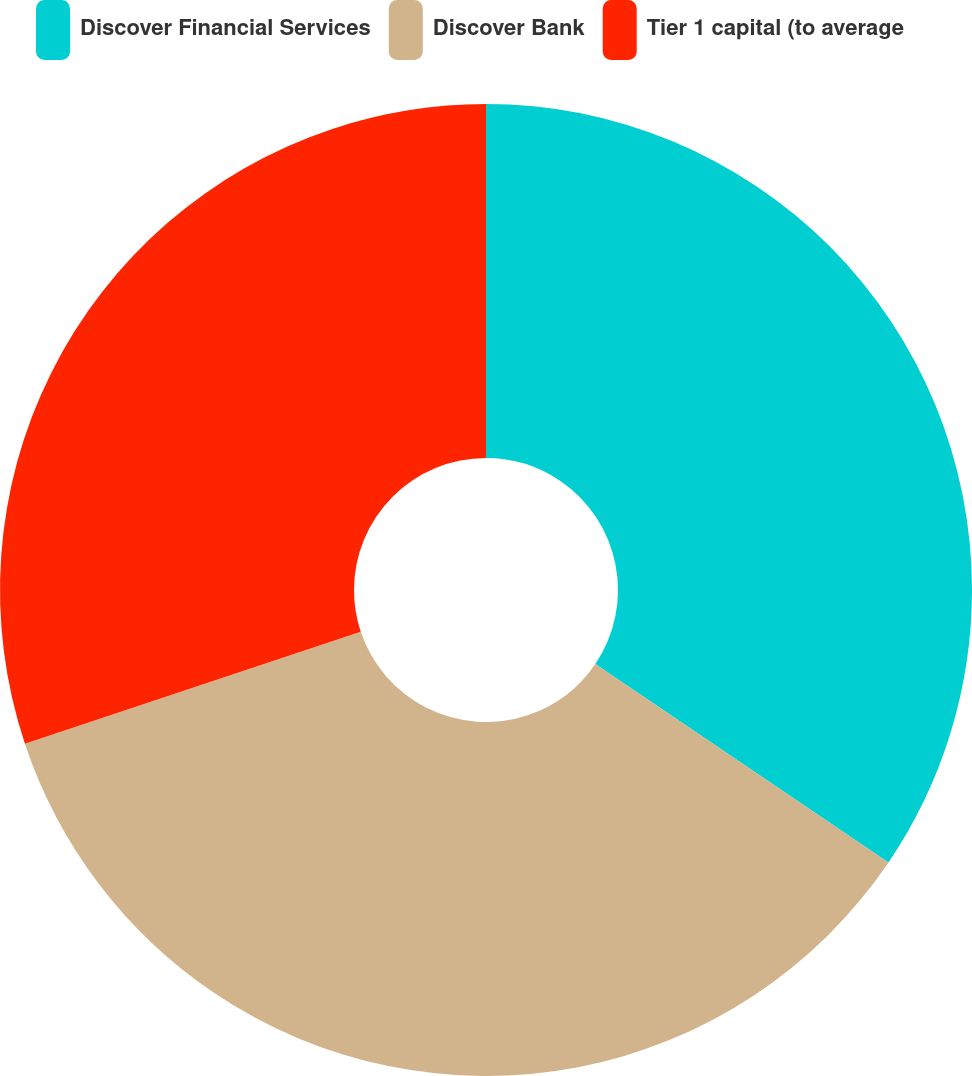Convert chart to OTSL. <chart><loc_0><loc_0><loc_500><loc_500><pie_chart><fcel>Discover Financial Services<fcel>Discover Bank<fcel>Tier 1 capital (to average<nl><fcel>34.47%<fcel>35.41%<fcel>30.12%<nl></chart> 